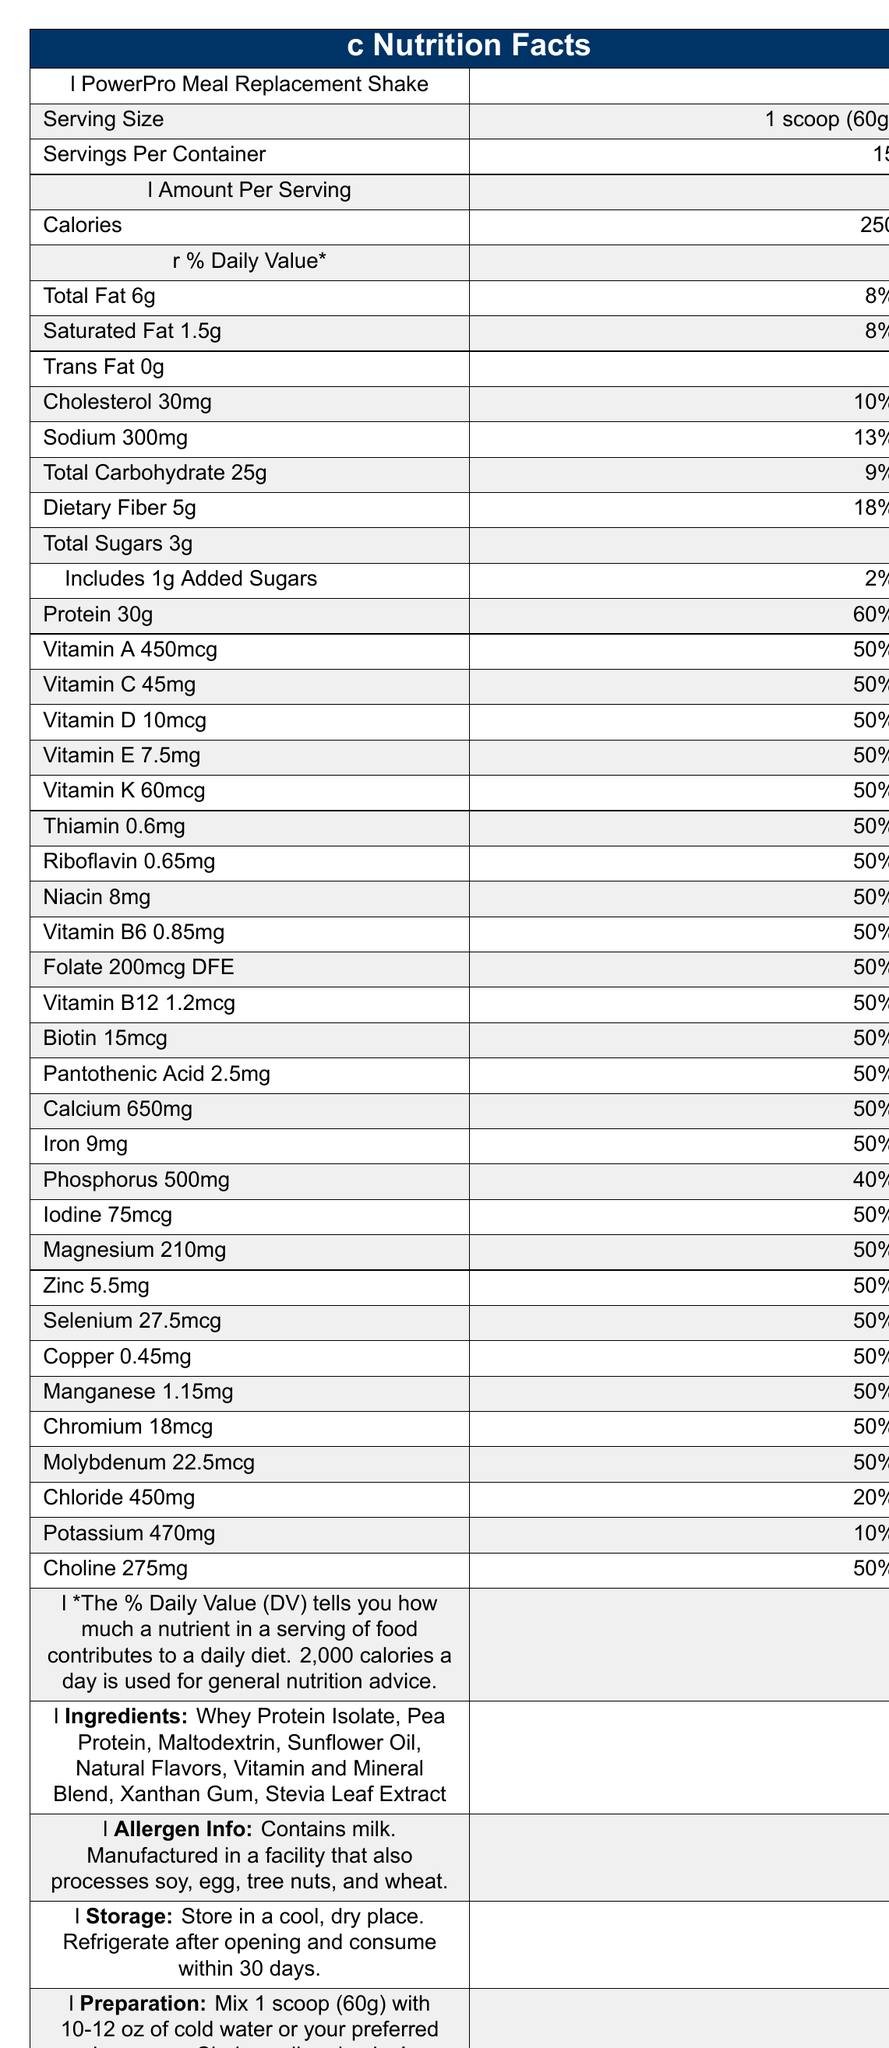what is the serving size for the PowerPro Meal Replacement Shake? The serving size is explicitly mentioned under the "Serving Size" heading.
Answer: 1 scoop (60g) how many calories are there per serving? The document states that there are 250 calories per serving under the "Calories" section.
Answer: 250 how much saturated fat does one serving contain? The amount of saturated fat is listed as 1.5g under the "Saturated Fat" section.
Answer: 1.5g what percentage of the daily value of sodium does one serving provide? The sodium content is 300mg, and it provides 13% of the daily value, as indicated in the document.
Answer: 13% list three ingredients in the PowerPro Meal Replacement Shake. The ingredients list includes Whey Protein Isolate, Pea Protein, and Maltodextrin among others.
Answer: Whey Protein Isolate, Pea Protein, Maltodextrin what vitamins and their percentages are included in this meal replacement shake? A. Vitamin A, Vitamin C, Vitamin D (50%) B. Vitamin A, Vitamin B12, Vitamin K (50%) C. Vitamin A, Vitamin E, Vitamin D (20%) Option A is correct as the vitamins listed (A, C, D) each account for 50% of the daily value.
Answer: A which nutrient has the highest daily value percentage in the shake? 1. Protein 2. Calcium 3. Potassium 4. Fiber Protein has the highest daily value percentage at 60%, compared to Calcium (50%), Potassium (10%), and Fiber (18%).
Answer: 1. Protein does the product contain any allergens? The document mentions that it contains milk and is manufactured in a facility that processes soy, egg, tree nuts, and wheat.
Answer: Yes describe the main features of the PowerPro Meal Replacement Shake. The main features section emphasizes the product’s target audience, nutritional composition, preparation convenience, and energy maintenance qualities.
Answer: The PowerPro Meal Replacement Shake is a high-protein, balanced meal replacement designed for busy professionals. It includes a robust mix of essential vitamins and minerals, supports muscle recovery and energy maintenance, and is convenient to prepare and store. It contains 250 calories per serving, 30g of protein, and a variety of micronutrients. what is the exact weight of one serving in grams? The serving size is clearly stated as 1 scoop, which is equivalent to 60 grams.
Answer: 60g how many grams of protein are in one serving? The document specifies that there are 30 grams of protein per serving.
Answer: 30g how many servings are there per container? The document states there are 15 servings per container.
Answer: 15 does the shake include any added sugars? The document lists "Includes 1g Added Sugars" under the carbohydrate section.
Answer: Yes, it includes 1g added sugars. is this product fortified with essential vitamins and minerals? The product is fortified with essential vitamins and minerals as found in the detailed nutrient section.
Answer: Yes what is the total amount of dietary fiber per serving? The dietary fiber content per serving is 5 grams.
Answer: 5g how many micrograms of vitamin K are included per serving? The document indicates that there are 60mcg of vitamin K per serving.
Answer: 60mcg what is the storage instruction given? The storage instructions are explicitly mentioned in the document.
Answer: Store in a cool, dry place. Refrigerate after opening and consume within 30 days. what is the percentage daily value for chloride provided per serving? The document lists chloride at 20% of the daily value.
Answer: 20% can you determine the exact manufacturing process for this product from the document? The document does not provide details about the exact manufacturing process, only allergen information related to the manufacturing facility.
Answer: Not enough information what kind of audience is this meal replacement shake targeting? The document specifically states the target audience for the product.
Answer: Busy professionals, administrators, and individuals seeking convenient, nutritious meal options 